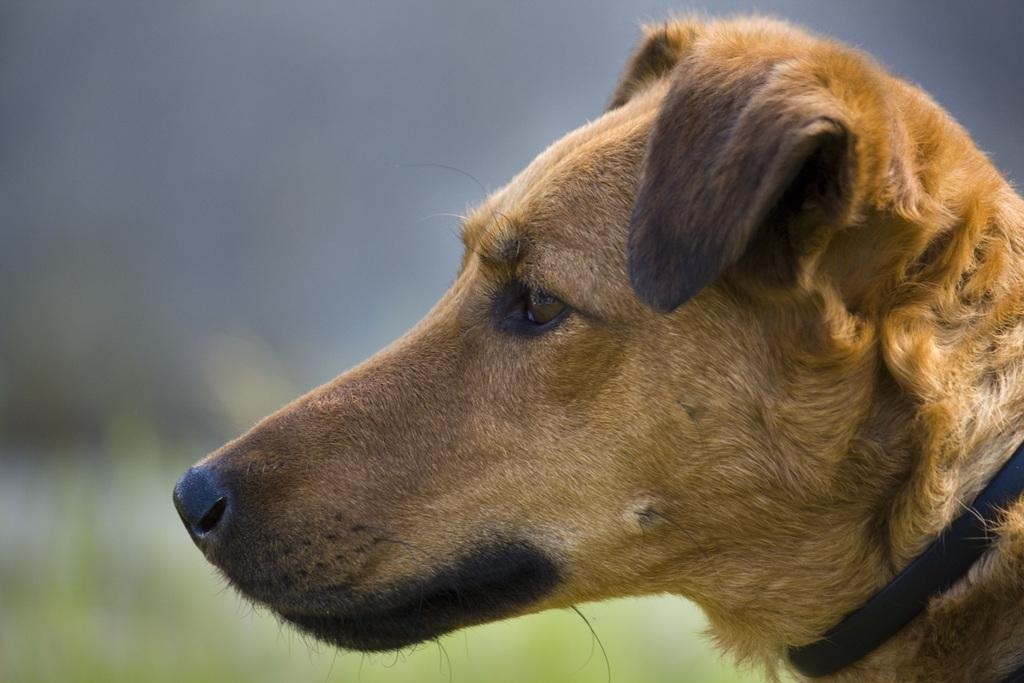What type of animal is in the image? There is a dog in the image. Can you describe the dog's appearance? The dog has brown and black coloring. What can be observed about the background of the image? The background of the image is blurred. What type of linen is being used to create the dog's fur in the image? There is no linen present in the image, as the dog's fur is a natural part of the dog's appearance. 